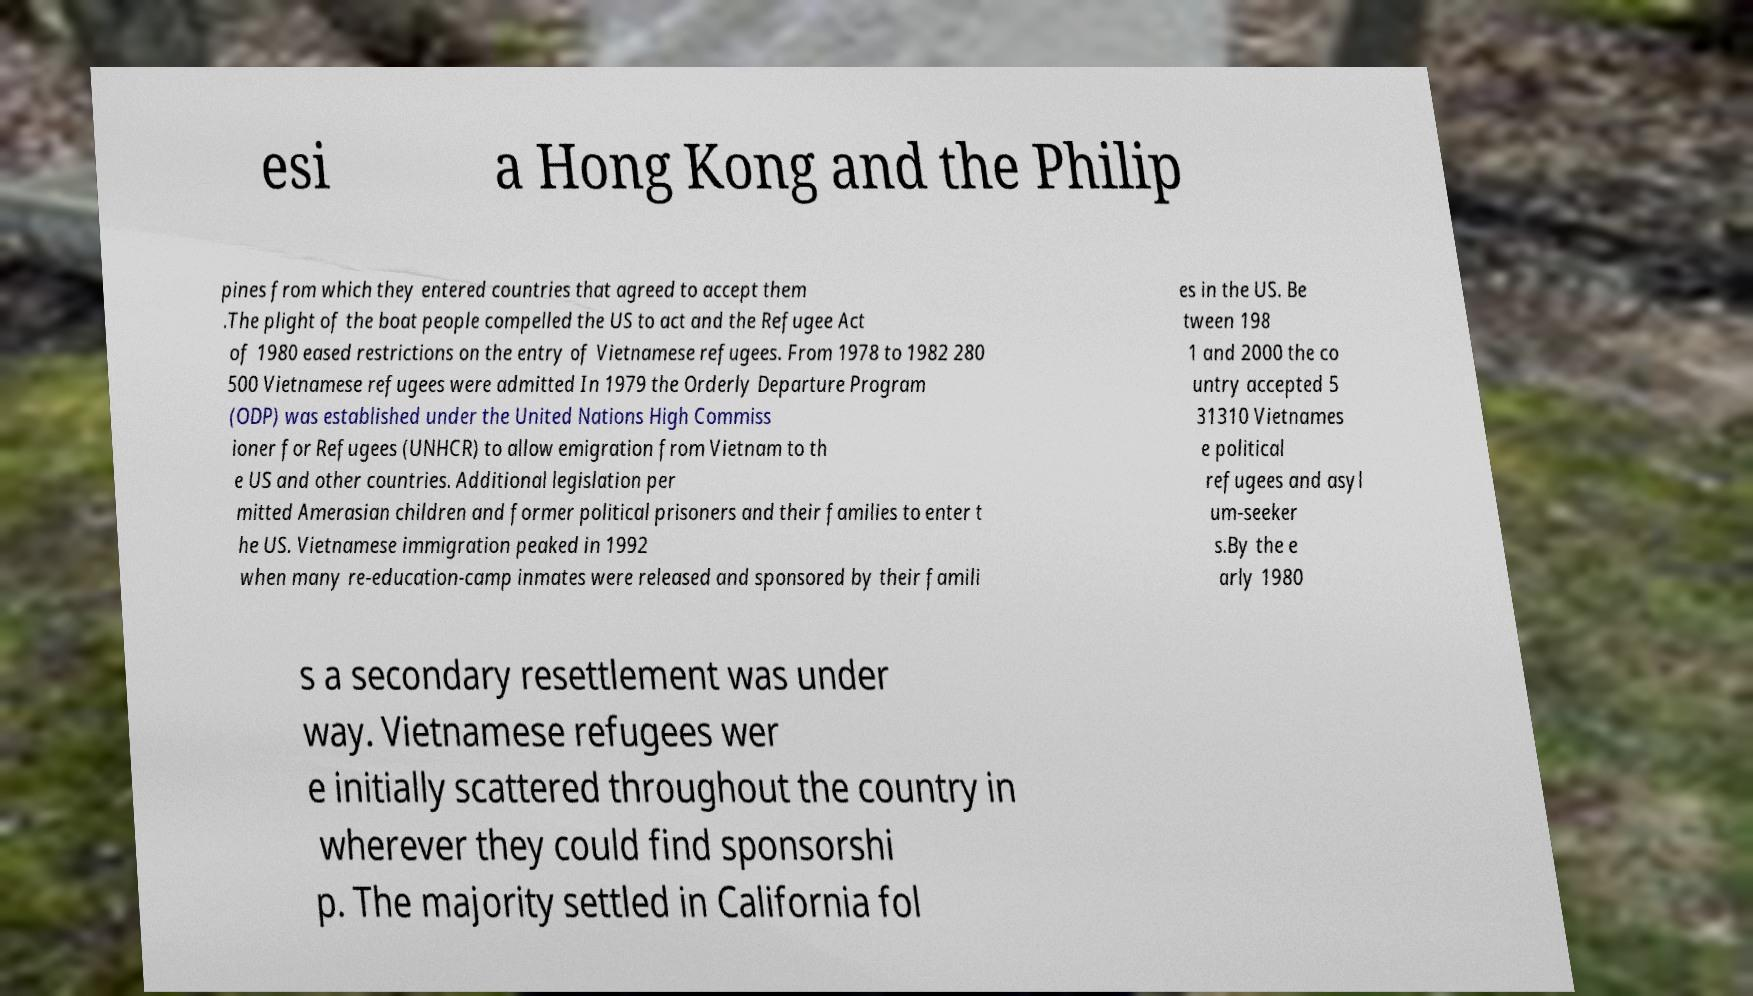Please identify and transcribe the text found in this image. esi a Hong Kong and the Philip pines from which they entered countries that agreed to accept them .The plight of the boat people compelled the US to act and the Refugee Act of 1980 eased restrictions on the entry of Vietnamese refugees. From 1978 to 1982 280 500 Vietnamese refugees were admitted In 1979 the Orderly Departure Program (ODP) was established under the United Nations High Commiss ioner for Refugees (UNHCR) to allow emigration from Vietnam to th e US and other countries. Additional legislation per mitted Amerasian children and former political prisoners and their families to enter t he US. Vietnamese immigration peaked in 1992 when many re-education-camp inmates were released and sponsored by their famili es in the US. Be tween 198 1 and 2000 the co untry accepted 5 31310 Vietnames e political refugees and asyl um-seeker s.By the e arly 1980 s a secondary resettlement was under way. Vietnamese refugees wer e initially scattered throughout the country in wherever they could find sponsorshi p. The majority settled in California fol 